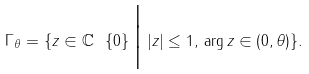Convert formula to latex. <formula><loc_0><loc_0><loc_500><loc_500>\Gamma _ { \theta } = \{ z \in { \mathbb { C } } \ \{ 0 \} \, \Big { | } \, | z | \leq 1 , \, \arg z \in ( 0 , \theta ) \} .</formula> 